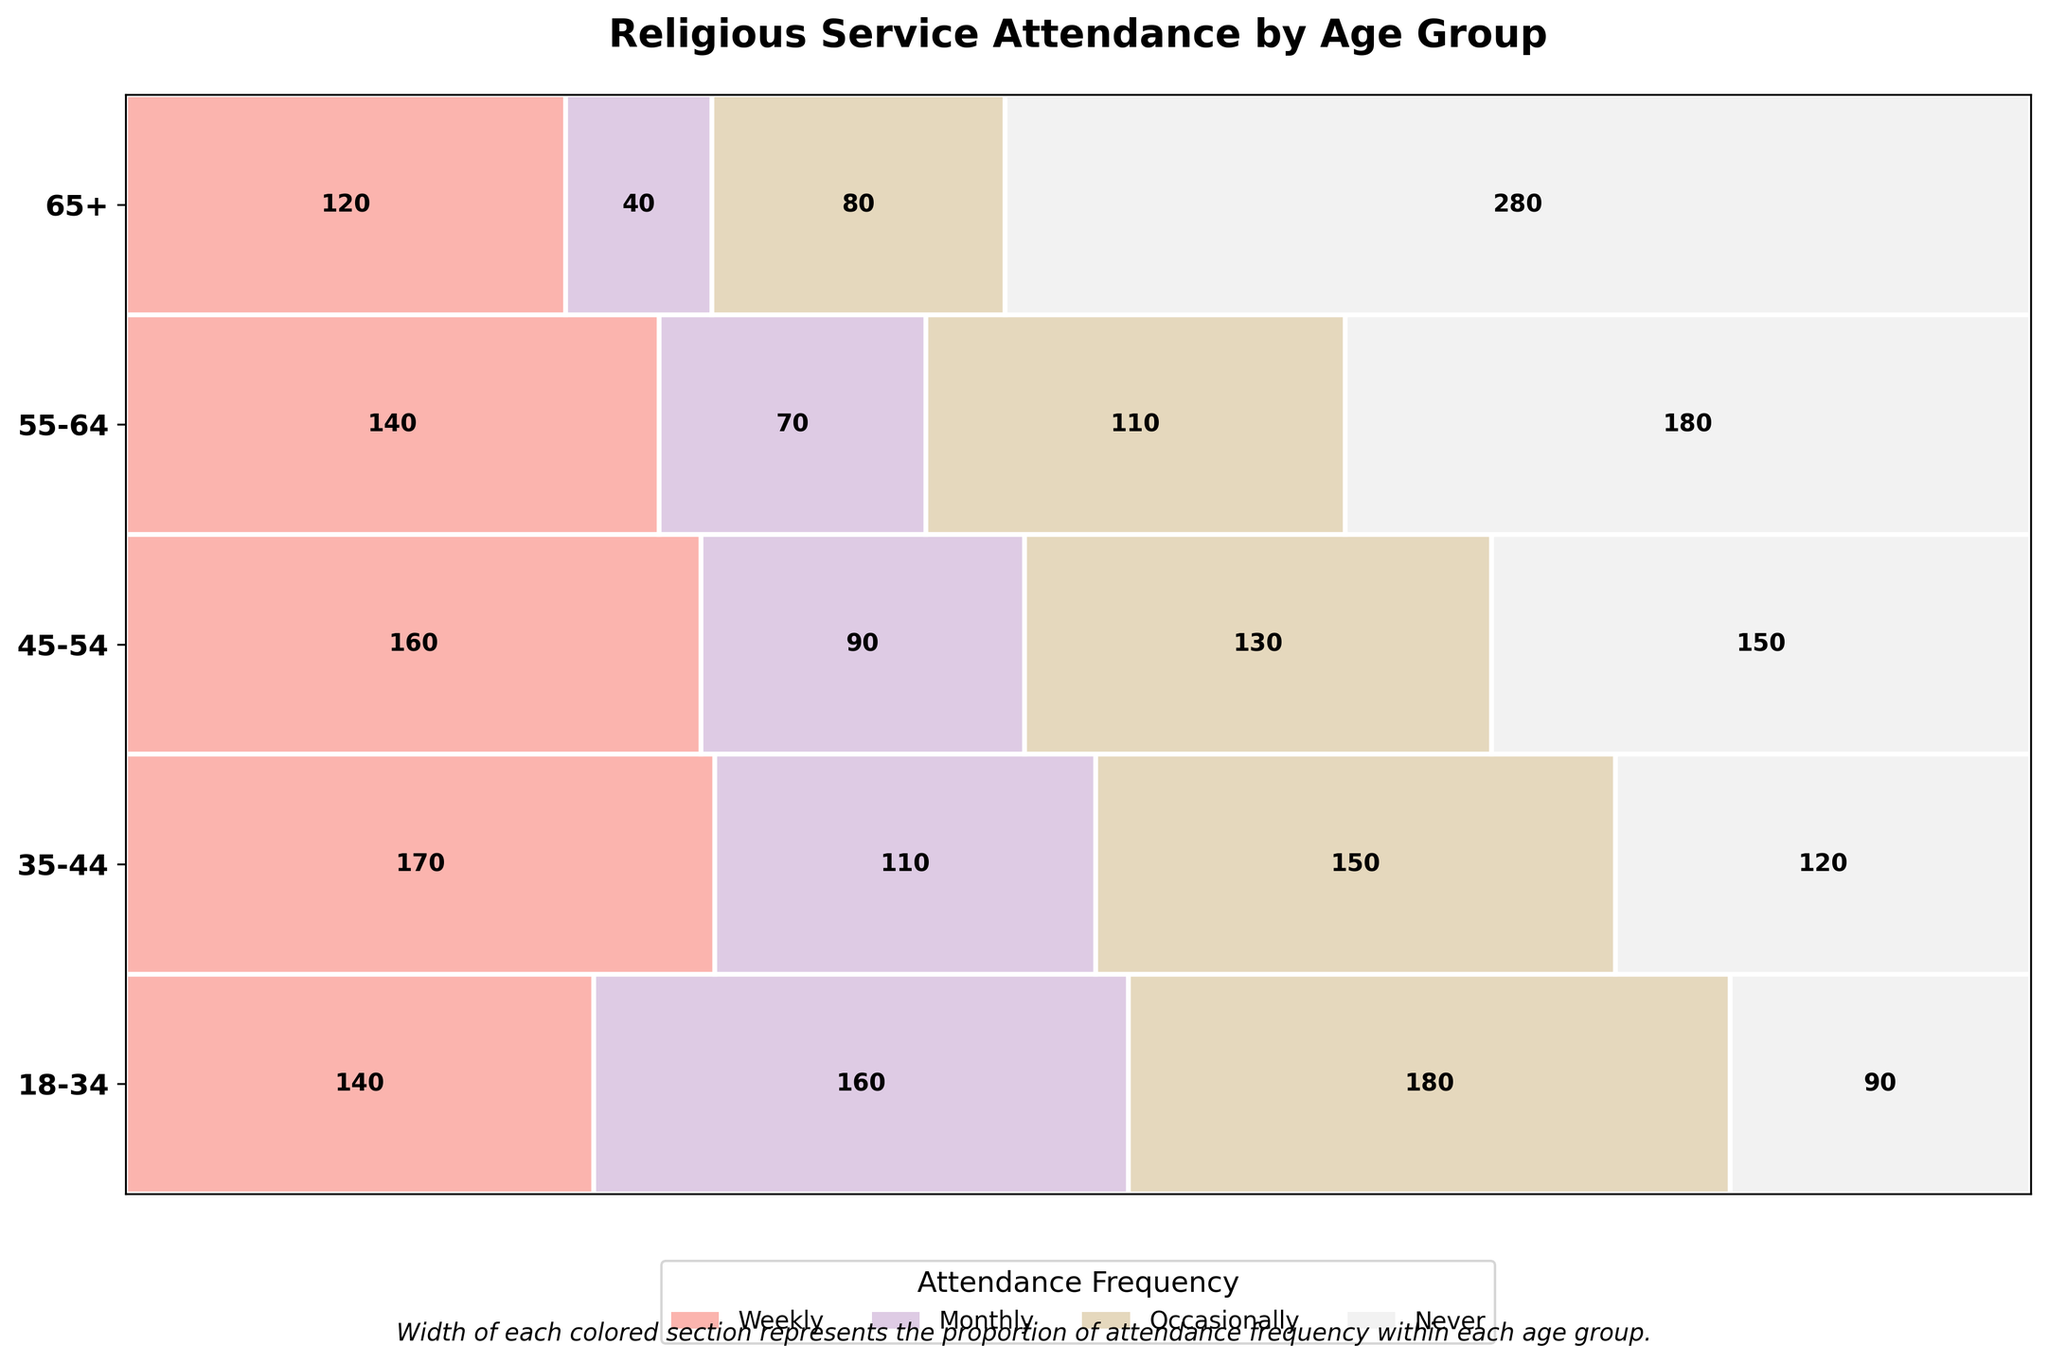Which age group has the highest count of people attending weekly? From the plot, look at the labeled numbers in the "Weekly" section for each age group; the group with the highest number in that section has the highest count for weekly attendance.
Answer: 65+ Which attendance frequency is most common among 18-34 age group? For the 18-34 age group, compare the sizes of the colored sections; the largest section represents the most common attendance frequency.
Answer: Occasionally In the 45-54 age group, what is the difference between the counts of weekly and never attending? Find the counts for "Weekly" and "Never" in the 45-54 group. Then, subtract the smaller count (Never) from the larger count (Weekly).
Answer: 60 Which age group has the smallest proportion of people who never attend religious services? For each age group, compare the width of the "Never" section; the group with the narrowest "Never" section has the smallest proportion of non-attendees.
Answer: 65+ How do the proportions of monthly attendees in the 55-64 and 35-44 age groups compare? Look at the widths of the "Monthly" sections for 55-64 and 35-44; the age group with the wider section has a higher proportion.
Answer: 35-44 Which age group has the highest diversity in attendance frequencies, meaning the counts are more evenly spread? Examine the widths of the sections for each attendance frequency within each age group; the group where sections are more evenly sized has the highest diversity.
Answer: 45-54 What is the combined count of people who never attend religious services in the 65+ and 55-64 age groups? Add the counts of "Never" attending for the 65+ group (40) and the 55-64 group (70).
Answer: 110 Which age group shows a significantly higher count for monthly attendance compared to occasional attendance? Compare the "Monthly" and "Occasionally" sections within all age groups to find the one with the largest positive difference.
Answer: 45-54 What percentage of the 35-44 age group attends religious services weekly? Divide the count of weekly attendees in the 35-44 age group (120) by the total count for that age group, then multiply by 100 to get the percentage: (120 / (120+170+150+110)) * 100.
Answer: 18.75% Is the total attendance count higher for the 18-34 or 55-64 age group? Add up the counts for all attendance frequencies within each group and compare the totals.
Answer: 18-34 